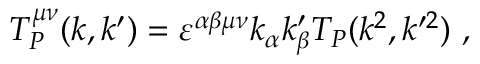<formula> <loc_0><loc_0><loc_500><loc_500>T _ { P } ^ { \mu \nu } ( k , k ^ { \prime } ) = \varepsilon ^ { \alpha \beta \mu \nu } k _ { \alpha } k _ { \beta } ^ { \prime } T _ { P } ( k ^ { 2 } , k ^ { \prime 2 } ) ,</formula> 